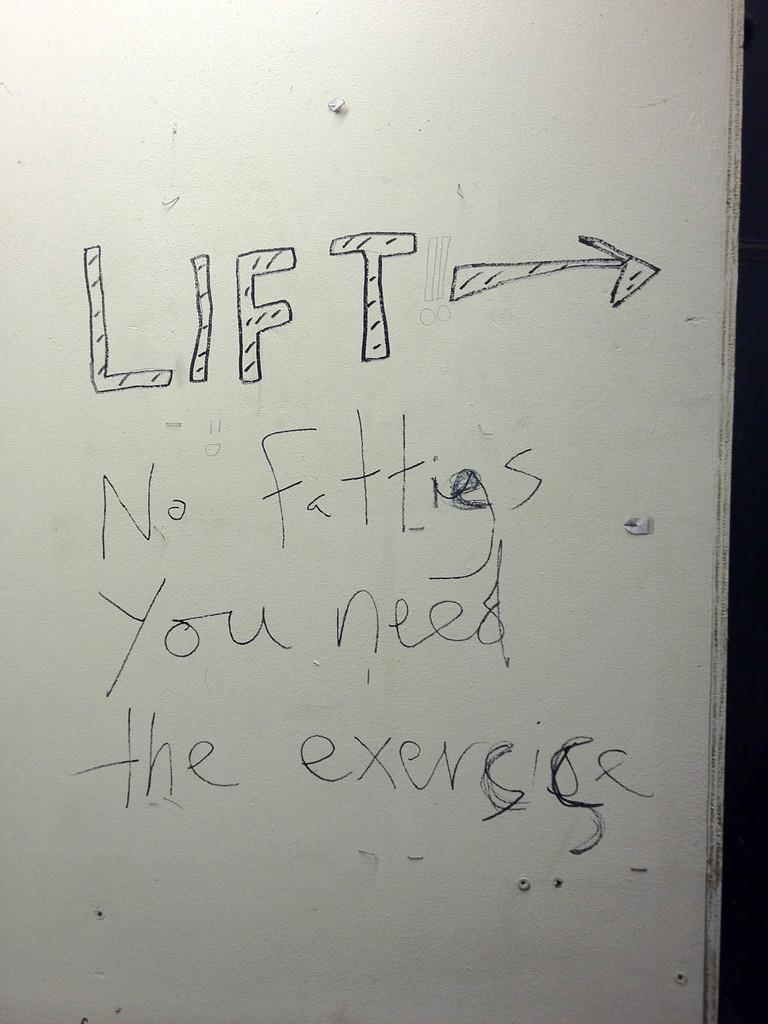Provide a one-sentence caption for the provided image. An insult is scrawled on a white door. 